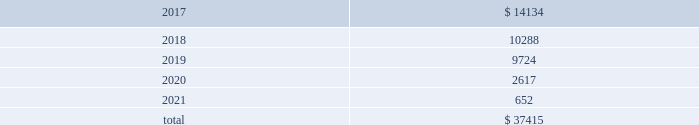Table of contents 17 .
Unconditional purchase obligations the company has entered into various unconditional purchase obligations which primarily include software licenses and long- term purchase contracts for network , communication and office maintenance services .
The company expended $ 7.2 million , $ 5.3 million and $ 2.9 million related to unconditional purchase obligations that existed as of the beginning of each year for the years ended december 31 , 2016 , 2015 and 2014 , respectively .
Future expenditures under unconditional purchase obligations in effect as of december 31 , 2016 are as follows : ( in thousands ) .
18 .
Restructuring during the fourth quarter of 2016 , the company initiated workforce realignment activities .
The company incurred $ 3.4 million in restructuring charges , or $ 2.4 million net of tax , during the year ended december 31 , 2016 .
The company expects to incur additional charges of $ 10 million - $ 15 million , or $ 7 million - $ 10 million net of tax , primarily during the first quarter of 2017 .
19 .
Employment-related settlement on february 15 , 2017 , the company entered into an employment-related settlement agreement .
In connection with the settlement agreement , the company will make a lump-sum payment of $ 4.7 million .
The charges related to this agreement are included in selling , general and administrative expense in the 2016 consolidated statement of income .
As part of the settlement agreement , all the claims initiated against the company will be withdrawn and a general release of all claims in favor of the company and all of its related entities was executed .
20 .
Contingencies and commitments the company is subject to various investigations , claims and legal proceedings that arise in the ordinary course of business , including commercial disputes , labor and employment matters , tax audits , alleged infringement of intellectual property rights and other matters .
In the opinion of the company , the resolution of pending matters is not expected to have a material adverse effect on the company's consolidated results of operations , cash flows or financial position .
However , each of these matters is subject to various uncertainties and it is possible that an unfavorable resolution of one or more of these proceedings could materially affect the company's results of operations , cash flows or financial position .
An indian subsidiary of the company has several service tax audits pending that have resulted in formal inquiries being received on transactions through mid-2012 .
The company could incur tax charges and related liabilities , including those related to the service tax audit case , of approximately $ 7 million .
The service tax issues raised in the company 2019s notices and inquiries are very similar to the case , m/s microsoft corporation ( i ) ( p ) ltd .
Vs commissioner of service tax , new delhi , wherein the delhi customs , excise and service tax appellate tribunal ( cestat ) has passed a favorable ruling to microsoft .
The company can provide no assurances on whether the microsoft case 2019s favorable ruling will be challenged in higher courts or on the impact that the present microsoft case 2019s decision will have on the company 2019s cases .
The company is uncertain as to when these service tax matters will be concluded .
A french subsidiary of the company received notice that the french taxing authority rejected the company's 2012 research and development credit .
The company has contested the decision .
However , if the company does not receive a favorable outcome , it could incur charges of approximately $ 0.8 million .
In addition , an unfavorable outcome could result in the authorities reviewing or rejecting $ 3.8 million of similar research and development credits for 2013 through the current year that are currently reflected as an asset .
The company can provide no assurances on the timing or outcome of this matter. .
What is the average of future expenditures , in thousands , from 2017-2021? 
Computations: (37415 / 5)
Answer: 7483.0. 